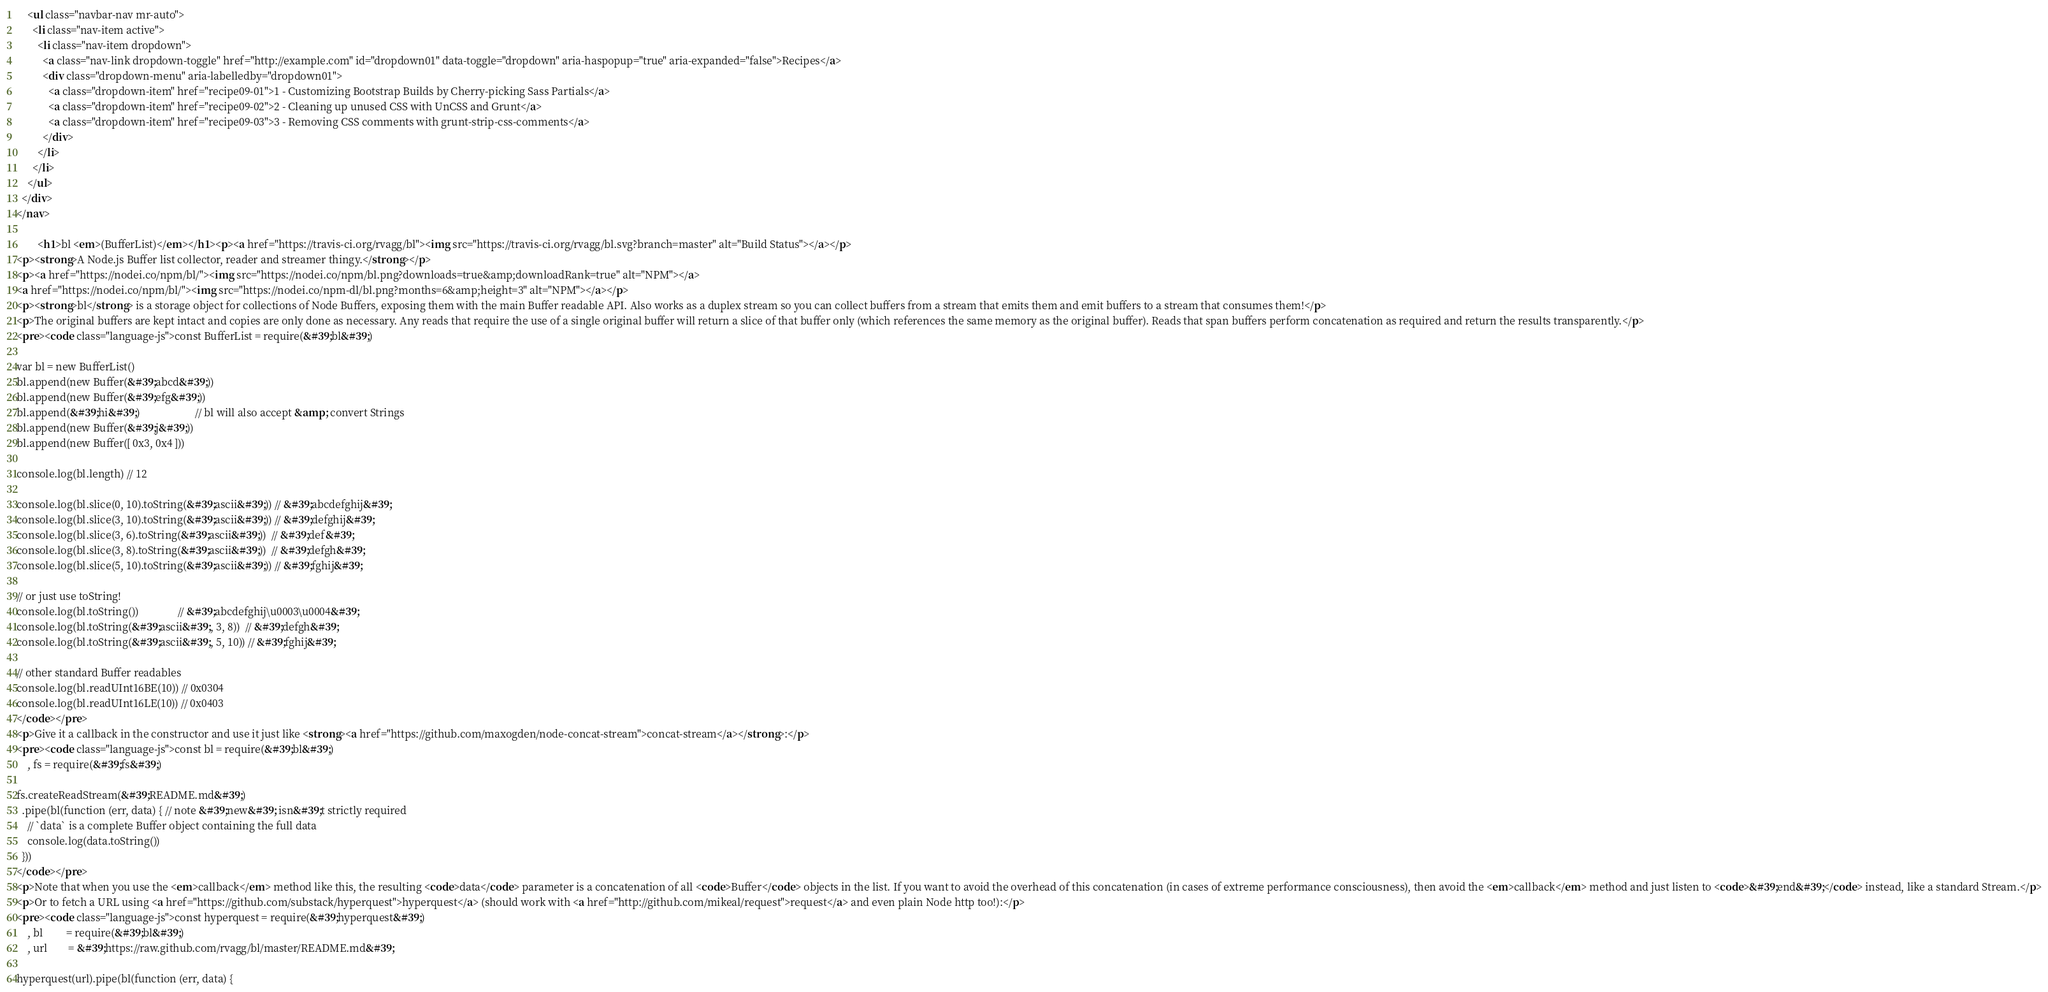<code> <loc_0><loc_0><loc_500><loc_500><_HTML_>    <ul class="navbar-nav mr-auto">
      <li class="nav-item active">
        <li class="nav-item dropdown">
          <a class="nav-link dropdown-toggle" href="http://example.com" id="dropdown01" data-toggle="dropdown" aria-haspopup="true" aria-expanded="false">Recipes</a>
          <div class="dropdown-menu" aria-labelledby="dropdown01">
            <a class="dropdown-item" href="recipe09-01">1 - Customizing Bootstrap Builds by Cherry-picking Sass Partials</a>
            <a class="dropdown-item" href="recipe09-02">2 - Cleaning up unused CSS with UnCSS and Grunt</a>
            <a class="dropdown-item" href="recipe09-03">3 - Removing CSS comments with grunt-strip-css-comments</a>
          </div>
        </li>
      </li>
    </ul>
  </div>
</nav>

        <h1>bl <em>(BufferList)</em></h1><p><a href="https://travis-ci.org/rvagg/bl"><img src="https://travis-ci.org/rvagg/bl.svg?branch=master" alt="Build Status"></a></p>
<p><strong>A Node.js Buffer list collector, reader and streamer thingy.</strong></p>
<p><a href="https://nodei.co/npm/bl/"><img src="https://nodei.co/npm/bl.png?downloads=true&amp;downloadRank=true" alt="NPM"></a>
<a href="https://nodei.co/npm/bl/"><img src="https://nodei.co/npm-dl/bl.png?months=6&amp;height=3" alt="NPM"></a></p>
<p><strong>bl</strong> is a storage object for collections of Node Buffers, exposing them with the main Buffer readable API. Also works as a duplex stream so you can collect buffers from a stream that emits them and emit buffers to a stream that consumes them!</p>
<p>The original buffers are kept intact and copies are only done as necessary. Any reads that require the use of a single original buffer will return a slice of that buffer only (which references the same memory as the original buffer). Reads that span buffers perform concatenation as required and return the results transparently.</p>
<pre><code class="language-js">const BufferList = require(&#39;bl&#39;)

var bl = new BufferList()
bl.append(new Buffer(&#39;abcd&#39;))
bl.append(new Buffer(&#39;efg&#39;))
bl.append(&#39;hi&#39;)                     // bl will also accept &amp; convert Strings
bl.append(new Buffer(&#39;j&#39;))
bl.append(new Buffer([ 0x3, 0x4 ]))

console.log(bl.length) // 12

console.log(bl.slice(0, 10).toString(&#39;ascii&#39;)) // &#39;abcdefghij&#39;
console.log(bl.slice(3, 10).toString(&#39;ascii&#39;)) // &#39;defghij&#39;
console.log(bl.slice(3, 6).toString(&#39;ascii&#39;))  // &#39;def&#39;
console.log(bl.slice(3, 8).toString(&#39;ascii&#39;))  // &#39;defgh&#39;
console.log(bl.slice(5, 10).toString(&#39;ascii&#39;)) // &#39;fghij&#39;

// or just use toString!
console.log(bl.toString())               // &#39;abcdefghij\u0003\u0004&#39;
console.log(bl.toString(&#39;ascii&#39;, 3, 8))  // &#39;defgh&#39;
console.log(bl.toString(&#39;ascii&#39;, 5, 10)) // &#39;fghij&#39;

// other standard Buffer readables
console.log(bl.readUInt16BE(10)) // 0x0304
console.log(bl.readUInt16LE(10)) // 0x0403
</code></pre>
<p>Give it a callback in the constructor and use it just like <strong><a href="https://github.com/maxogden/node-concat-stream">concat-stream</a></strong>:</p>
<pre><code class="language-js">const bl = require(&#39;bl&#39;)
    , fs = require(&#39;fs&#39;)

fs.createReadStream(&#39;README.md&#39;)
  .pipe(bl(function (err, data) { // note &#39;new&#39; isn&#39;t strictly required
    // `data` is a complete Buffer object containing the full data
    console.log(data.toString())
  }))
</code></pre>
<p>Note that when you use the <em>callback</em> method like this, the resulting <code>data</code> parameter is a concatenation of all <code>Buffer</code> objects in the list. If you want to avoid the overhead of this concatenation (in cases of extreme performance consciousness), then avoid the <em>callback</em> method and just listen to <code>&#39;end&#39;</code> instead, like a standard Stream.</p>
<p>Or to fetch a URL using <a href="https://github.com/substack/hyperquest">hyperquest</a> (should work with <a href="http://github.com/mikeal/request">request</a> and even plain Node http too!):</p>
<pre><code class="language-js">const hyperquest = require(&#39;hyperquest&#39;)
    , bl         = require(&#39;bl&#39;)
    , url        = &#39;https://raw.github.com/rvagg/bl/master/README.md&#39;

hyperquest(url).pipe(bl(function (err, data) {</code> 